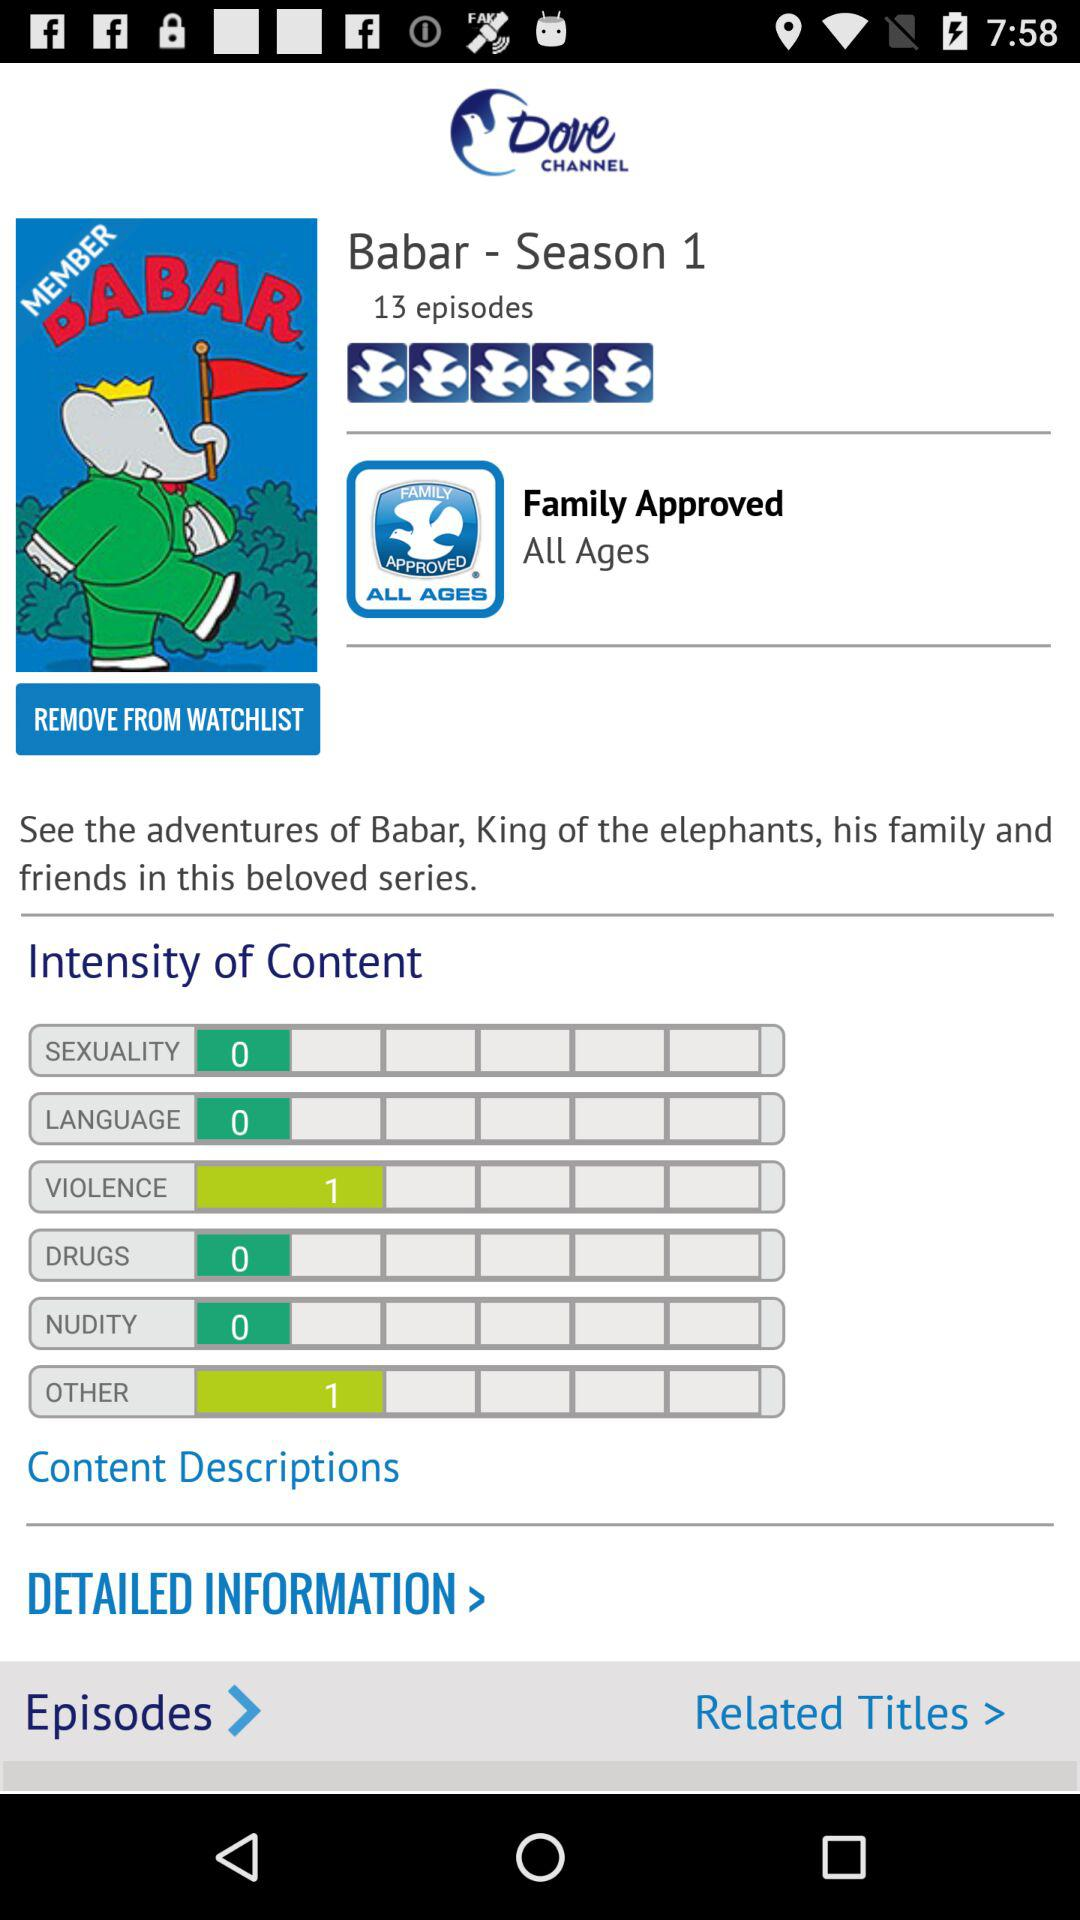How many episodes are there of "Babar - Season 1"? There are 13 episodes. 